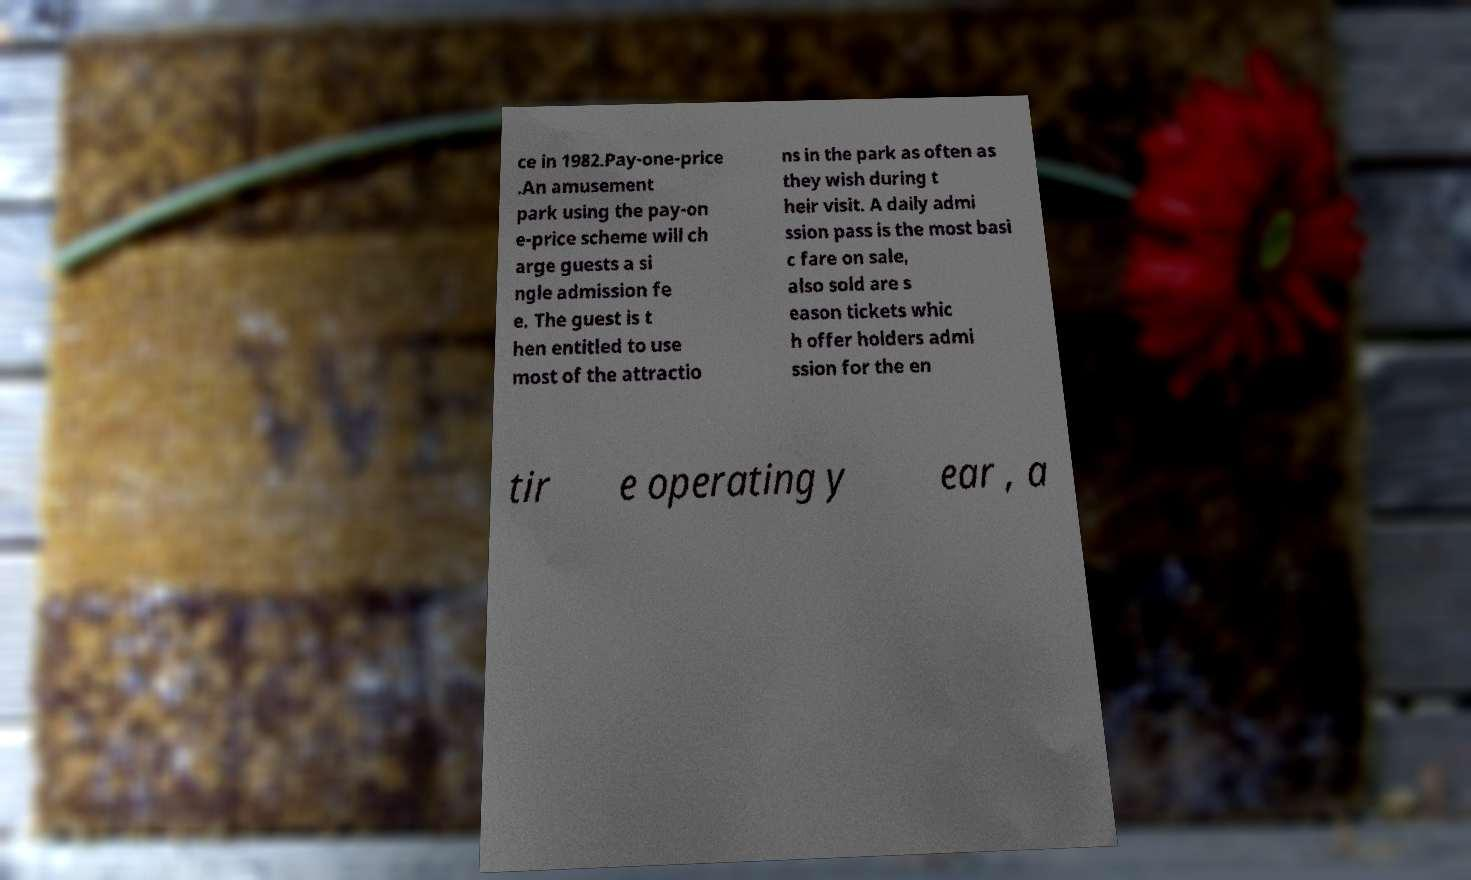Please identify and transcribe the text found in this image. ce in 1982.Pay-one-price .An amusement park using the pay-on e-price scheme will ch arge guests a si ngle admission fe e. The guest is t hen entitled to use most of the attractio ns in the park as often as they wish during t heir visit. A daily admi ssion pass is the most basi c fare on sale, also sold are s eason tickets whic h offer holders admi ssion for the en tir e operating y ear , a 